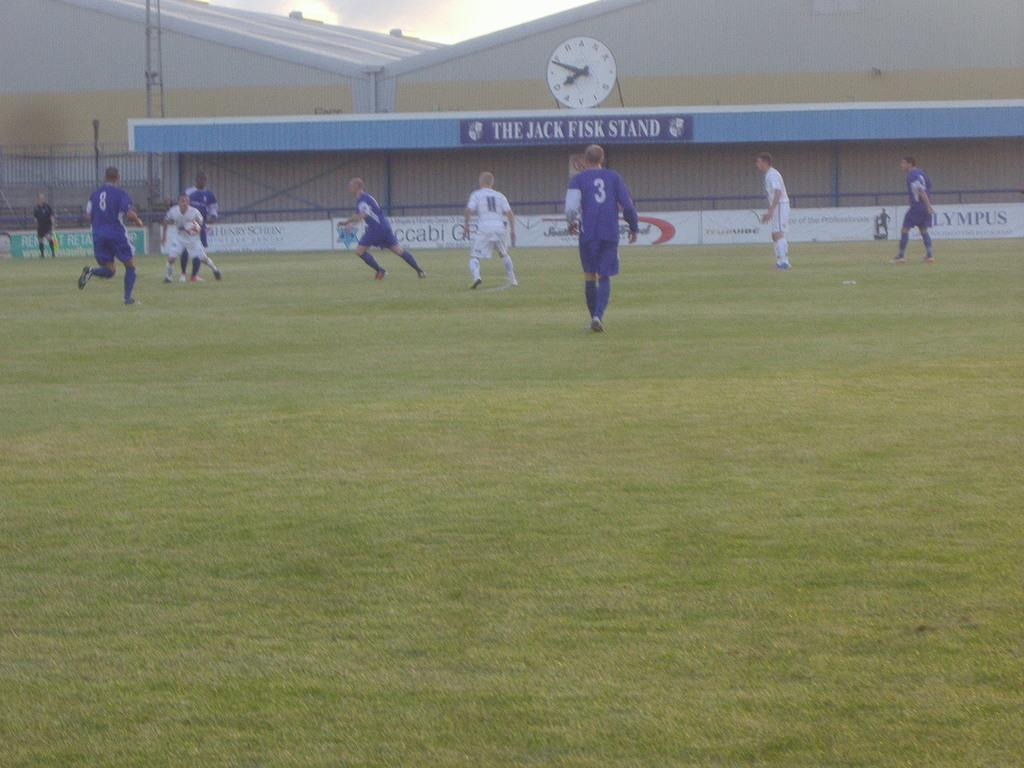<image>
Present a compact description of the photo's key features. A group of people play on a field in front of the Jack Fisk stand. 